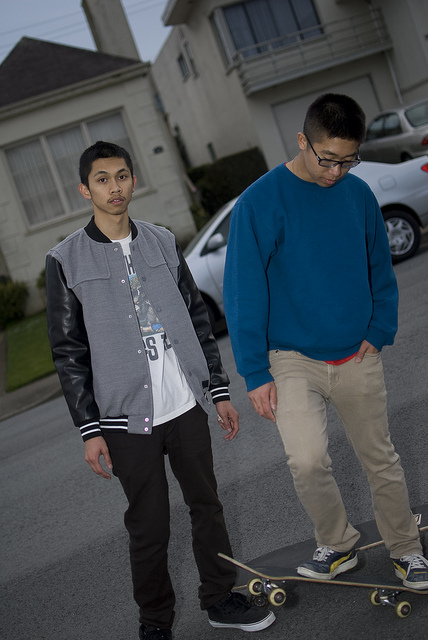What are the two individuals doing? They seem to be enjoying a casual skateboarding session together on what looks like a quiet residential street. 